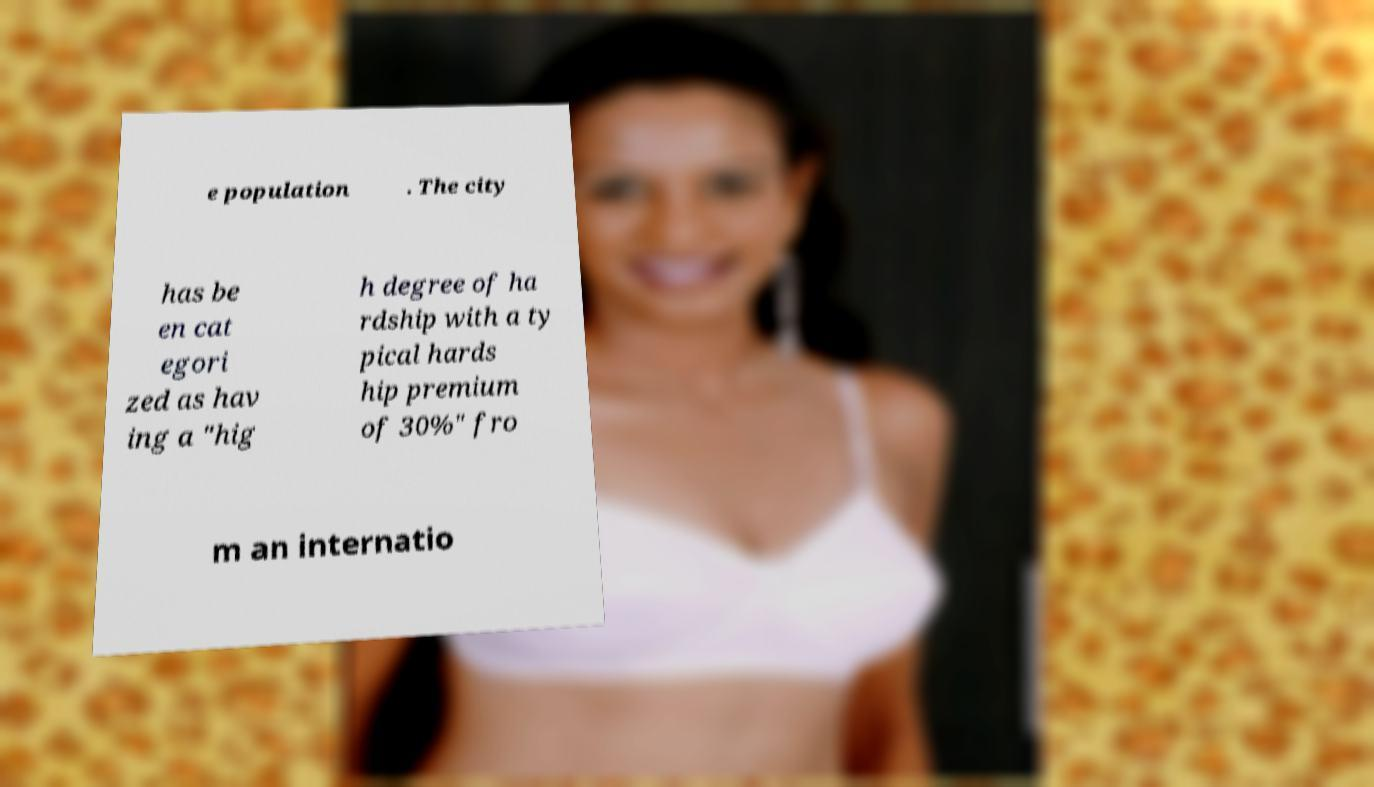I need the written content from this picture converted into text. Can you do that? e population . The city has be en cat egori zed as hav ing a "hig h degree of ha rdship with a ty pical hards hip premium of 30%" fro m an internatio 